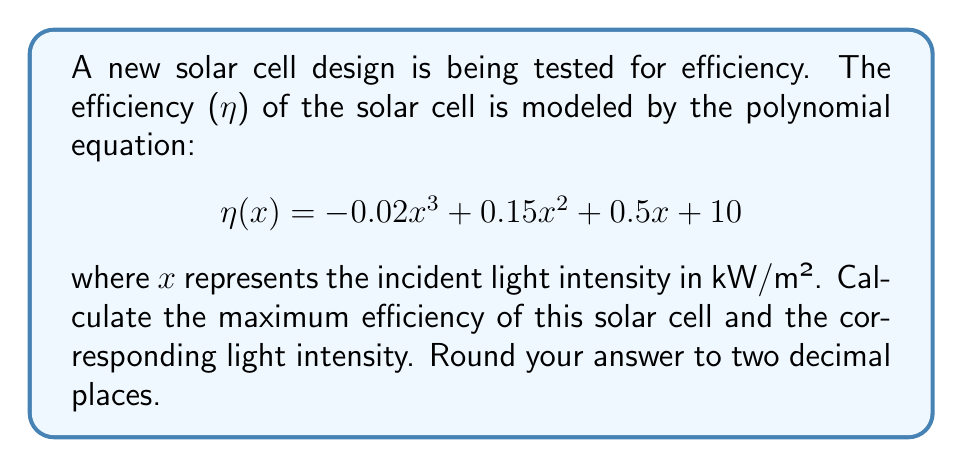Provide a solution to this math problem. To find the maximum efficiency, we need to find the maximum value of the function $\eta(x)$. This occurs where the derivative of $\eta(x)$ is zero.

1) First, let's find the derivative of $\eta(x)$:
   $$\eta'(x) = -0.06x^2 + 0.30x + 0.5$$

2) Set $\eta'(x) = 0$ and solve for $x$:
   $$-0.06x^2 + 0.30x + 0.5 = 0$$

3) This is a quadratic equation. We can solve it using the quadratic formula:
   $$x = \frac{-b \pm \sqrt{b^2 - 4ac}}{2a}$$
   where $a = -0.06$, $b = 0.30$, and $c = 0.5$

4) Substituting these values:
   $$x = \frac{-0.30 \pm \sqrt{0.30^2 - 4(-0.06)(0.5)}}{2(-0.06)}$$
   $$= \frac{-0.30 \pm \sqrt{0.09 + 0.12}}{-0.12}$$
   $$= \frac{-0.30 \pm \sqrt{0.21}}{-0.12}$$
   $$= \frac{-0.30 \pm 0.458}{-0.12}$$

5) This gives us two solutions:
   $$x_1 = \frac{-0.30 + 0.458}{-0.12} = 1.32$$
   $$x_2 = \frac{-0.30 - 0.458}{-0.12} = 6.32$$

6) To determine which solution gives the maximum, we can check the second derivative:
   $$\eta''(x) = -0.12x + 0.30$$
   At $x = 1.32$, $\eta''(1.32) = 0.1416 > 0$, indicating a local minimum.
   At $x = 6.32$, $\eta''(6.32) = -0.4584 < 0$, indicating a local maximum.

7) Therefore, the maximum efficiency occurs at $x = 6.32$ kW/m².

8) To find the maximum efficiency, we substitute this value back into the original equation:
   $$\eta(6.32) = -0.02(6.32)^3 + 0.15(6.32)^2 + 0.5(6.32) + 10$$
   $$= -5.06 + 5.99 + 3.16 + 10$$
   $$= 14.09$$

Therefore, the maximum efficiency is 14.09% at a light intensity of 6.32 kW/m².
Answer: The maximum efficiency is 14.09% at a light intensity of 6.32 kW/m². 